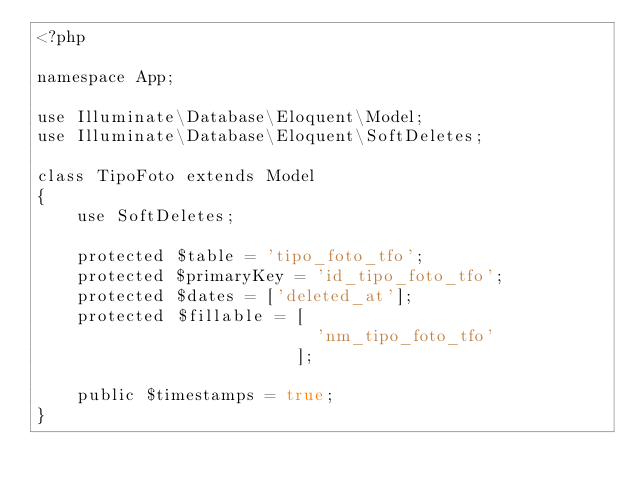<code> <loc_0><loc_0><loc_500><loc_500><_PHP_><?php

namespace App;

use Illuminate\Database\Eloquent\Model;
use Illuminate\Database\Eloquent\SoftDeletes;

class TipoFoto extends Model
{
    use SoftDeletes;
    
    protected $table = 'tipo_foto_tfo';
    protected $primaryKey = 'id_tipo_foto_tfo';
    protected $dates = ['deleted_at'];
    protected $fillable = [
                            'nm_tipo_foto_tfo'
                          ];

    public $timestamps = true;
}
</code> 